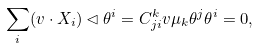Convert formula to latex. <formula><loc_0><loc_0><loc_500><loc_500>\sum _ { i } ( v \cdot X _ { i } ) \lhd \theta ^ { i } = C ^ { k } _ { j i } v \mu _ { k } \theta ^ { j } \theta ^ { i } = 0 ,</formula> 